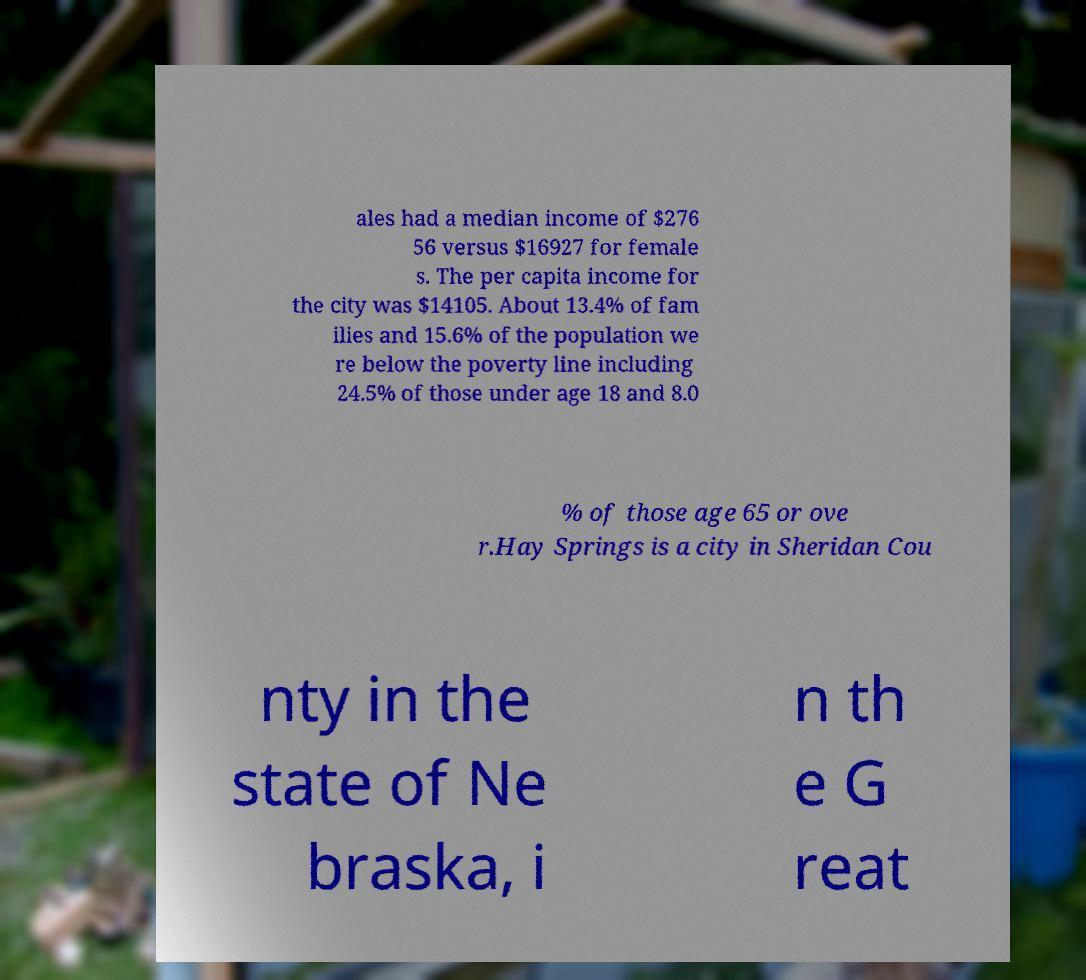I need the written content from this picture converted into text. Can you do that? ales had a median income of $276 56 versus $16927 for female s. The per capita income for the city was $14105. About 13.4% of fam ilies and 15.6% of the population we re below the poverty line including 24.5% of those under age 18 and 8.0 % of those age 65 or ove r.Hay Springs is a city in Sheridan Cou nty in the state of Ne braska, i n th e G reat 